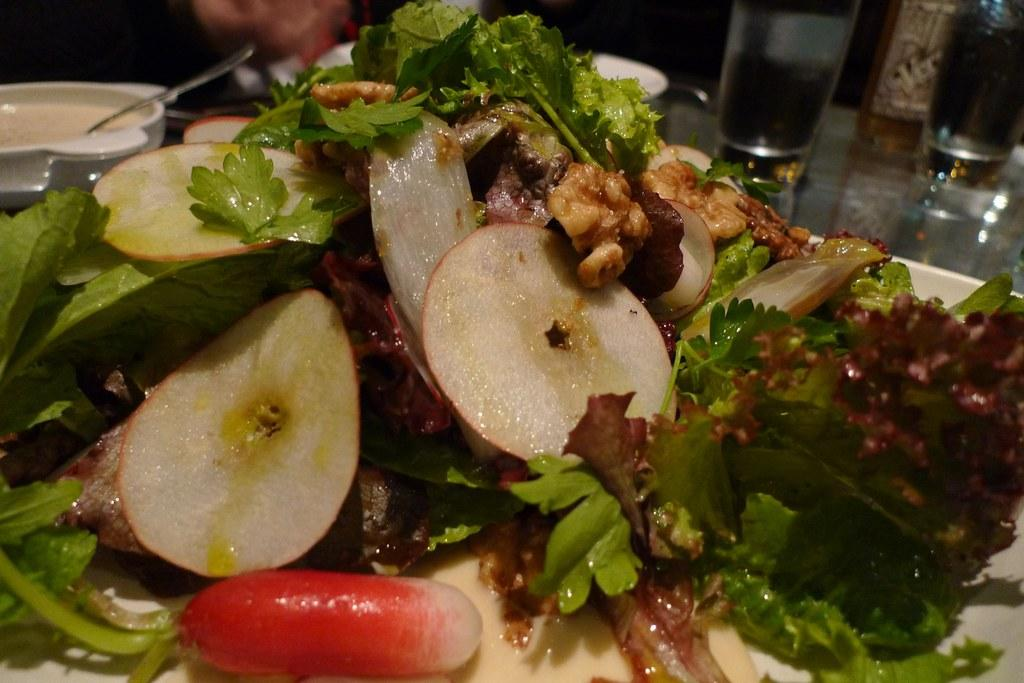What piece of furniture is visible in the image? There is a table in the image. What is placed on the table? There is a serving plate with food on the table. What type of drinking vessels are present on the table? Glass tumblers are present on the table. What is used for holding sauce or condiments on the table? There is a sauce bowl with a spoon in it on the table. What type of animal can be seen turning the page of a book in the image? There is no animal or book present in the image; it only features a table with various items on it. 